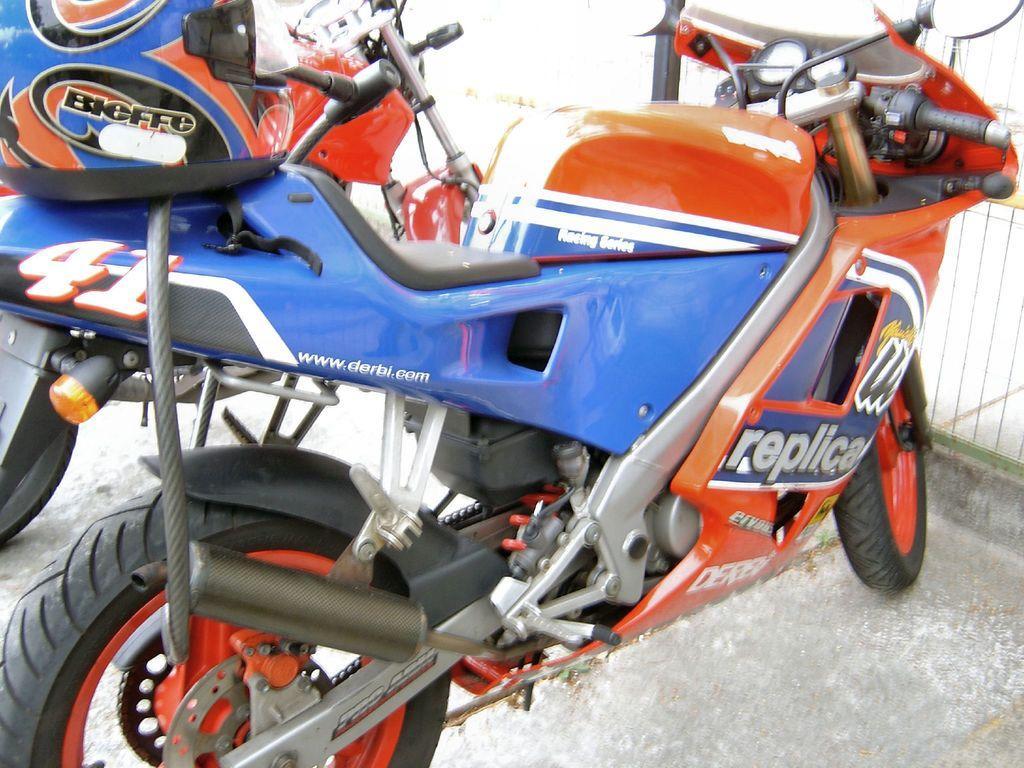Please provide a concise description of this image. In this image I can see two motorcycles and a blue colour helmet. I can also see something is written at few places. 